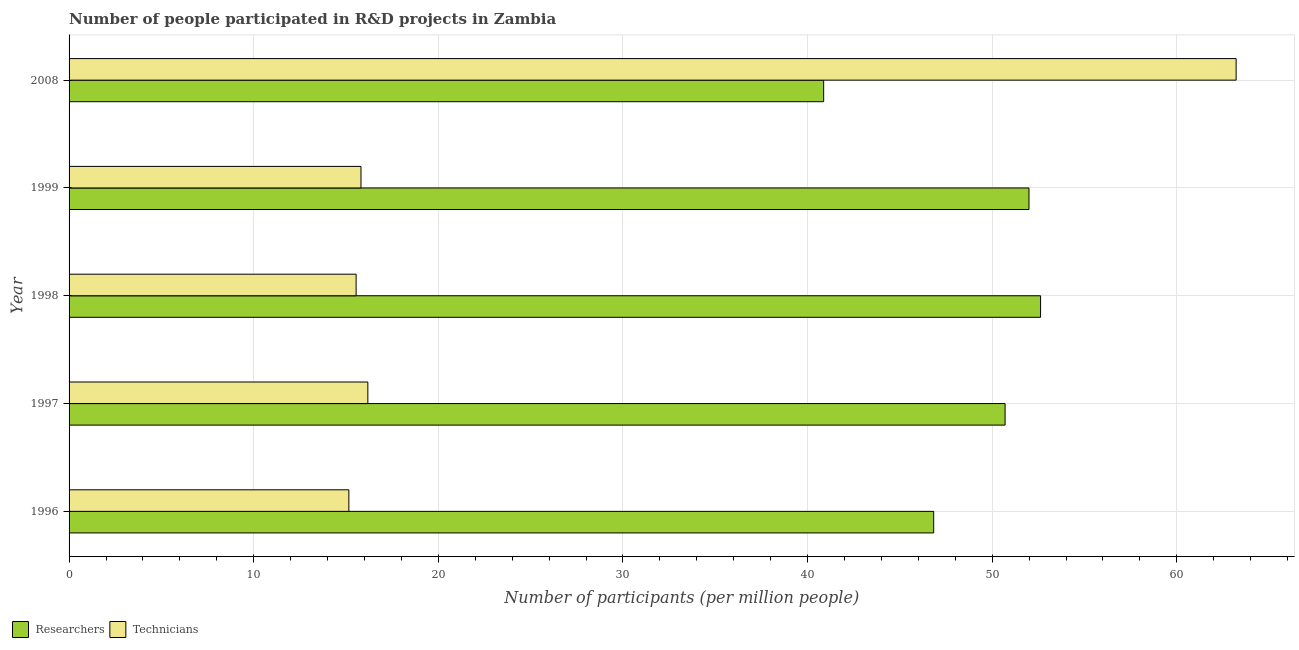How many different coloured bars are there?
Ensure brevity in your answer.  2. What is the label of the 4th group of bars from the top?
Your response must be concise. 1997. In how many cases, is the number of bars for a given year not equal to the number of legend labels?
Offer a terse response. 0. What is the number of researchers in 2008?
Your answer should be compact. 40.87. Across all years, what is the maximum number of technicians?
Your answer should be very brief. 63.21. Across all years, what is the minimum number of researchers?
Make the answer very short. 40.87. What is the total number of researchers in the graph?
Your answer should be compact. 243.01. What is the difference between the number of researchers in 1998 and that in 2008?
Ensure brevity in your answer.  11.75. What is the difference between the number of technicians in 1997 and the number of researchers in 2008?
Your answer should be very brief. -24.69. What is the average number of researchers per year?
Keep it short and to the point. 48.6. In the year 2008, what is the difference between the number of researchers and number of technicians?
Provide a short and direct response. -22.34. In how many years, is the number of technicians greater than 20 ?
Ensure brevity in your answer.  1. What is the ratio of the number of technicians in 1996 to that in 1997?
Give a very brief answer. 0.94. Is the number of researchers in 1996 less than that in 1997?
Keep it short and to the point. Yes. Is the difference between the number of researchers in 1997 and 1998 greater than the difference between the number of technicians in 1997 and 1998?
Keep it short and to the point. No. What is the difference between the highest and the second highest number of technicians?
Your answer should be very brief. 47.03. What is the difference between the highest and the lowest number of researchers?
Offer a very short reply. 11.75. What does the 1st bar from the top in 1999 represents?
Offer a very short reply. Technicians. What does the 2nd bar from the bottom in 1997 represents?
Give a very brief answer. Technicians. Are all the bars in the graph horizontal?
Ensure brevity in your answer.  Yes. How many years are there in the graph?
Give a very brief answer. 5. What is the difference between two consecutive major ticks on the X-axis?
Your response must be concise. 10. Are the values on the major ticks of X-axis written in scientific E-notation?
Provide a succinct answer. No. How are the legend labels stacked?
Provide a short and direct response. Horizontal. What is the title of the graph?
Keep it short and to the point. Number of people participated in R&D projects in Zambia. Does "Rural Population" appear as one of the legend labels in the graph?
Provide a short and direct response. No. What is the label or title of the X-axis?
Give a very brief answer. Number of participants (per million people). What is the label or title of the Y-axis?
Provide a succinct answer. Year. What is the Number of participants (per million people) of Researchers in 1996?
Your response must be concise. 46.83. What is the Number of participants (per million people) of Technicians in 1996?
Ensure brevity in your answer.  15.15. What is the Number of participants (per million people) in Researchers in 1997?
Provide a short and direct response. 50.7. What is the Number of participants (per million people) of Technicians in 1997?
Provide a short and direct response. 16.18. What is the Number of participants (per million people) of Researchers in 1998?
Offer a terse response. 52.62. What is the Number of participants (per million people) of Technicians in 1998?
Ensure brevity in your answer.  15.55. What is the Number of participants (per million people) of Researchers in 1999?
Make the answer very short. 51.99. What is the Number of participants (per million people) in Technicians in 1999?
Keep it short and to the point. 15.81. What is the Number of participants (per million people) in Researchers in 2008?
Your response must be concise. 40.87. What is the Number of participants (per million people) of Technicians in 2008?
Provide a succinct answer. 63.21. Across all years, what is the maximum Number of participants (per million people) of Researchers?
Your response must be concise. 52.62. Across all years, what is the maximum Number of participants (per million people) in Technicians?
Make the answer very short. 63.21. Across all years, what is the minimum Number of participants (per million people) in Researchers?
Your response must be concise. 40.87. Across all years, what is the minimum Number of participants (per million people) of Technicians?
Provide a succinct answer. 15.15. What is the total Number of participants (per million people) in Researchers in the graph?
Offer a very short reply. 243.01. What is the total Number of participants (per million people) in Technicians in the graph?
Offer a very short reply. 125.91. What is the difference between the Number of participants (per million people) of Researchers in 1996 and that in 1997?
Your answer should be compact. -3.87. What is the difference between the Number of participants (per million people) in Technicians in 1996 and that in 1997?
Ensure brevity in your answer.  -1.03. What is the difference between the Number of participants (per million people) of Researchers in 1996 and that in 1998?
Give a very brief answer. -5.79. What is the difference between the Number of participants (per million people) in Technicians in 1996 and that in 1998?
Give a very brief answer. -0.39. What is the difference between the Number of participants (per million people) in Researchers in 1996 and that in 1999?
Your answer should be very brief. -5.16. What is the difference between the Number of participants (per million people) of Technicians in 1996 and that in 1999?
Offer a very short reply. -0.66. What is the difference between the Number of participants (per million people) of Researchers in 1996 and that in 2008?
Your answer should be very brief. 5.96. What is the difference between the Number of participants (per million people) in Technicians in 1996 and that in 2008?
Offer a terse response. -48.06. What is the difference between the Number of participants (per million people) in Researchers in 1997 and that in 1998?
Your response must be concise. -1.92. What is the difference between the Number of participants (per million people) of Technicians in 1997 and that in 1998?
Your answer should be very brief. 0.64. What is the difference between the Number of participants (per million people) in Researchers in 1997 and that in 1999?
Provide a short and direct response. -1.29. What is the difference between the Number of participants (per million people) in Technicians in 1997 and that in 1999?
Offer a terse response. 0.37. What is the difference between the Number of participants (per million people) in Researchers in 1997 and that in 2008?
Your answer should be compact. 9.83. What is the difference between the Number of participants (per million people) of Technicians in 1997 and that in 2008?
Give a very brief answer. -47.03. What is the difference between the Number of participants (per million people) in Researchers in 1998 and that in 1999?
Offer a very short reply. 0.63. What is the difference between the Number of participants (per million people) in Technicians in 1998 and that in 1999?
Your answer should be very brief. -0.26. What is the difference between the Number of participants (per million people) in Researchers in 1998 and that in 2008?
Your response must be concise. 11.75. What is the difference between the Number of participants (per million people) of Technicians in 1998 and that in 2008?
Offer a very short reply. -47.67. What is the difference between the Number of participants (per million people) in Researchers in 1999 and that in 2008?
Offer a very short reply. 11.12. What is the difference between the Number of participants (per million people) in Technicians in 1999 and that in 2008?
Your answer should be very brief. -47.4. What is the difference between the Number of participants (per million people) of Researchers in 1996 and the Number of participants (per million people) of Technicians in 1997?
Provide a succinct answer. 30.65. What is the difference between the Number of participants (per million people) of Researchers in 1996 and the Number of participants (per million people) of Technicians in 1998?
Ensure brevity in your answer.  31.28. What is the difference between the Number of participants (per million people) in Researchers in 1996 and the Number of participants (per million people) in Technicians in 1999?
Offer a very short reply. 31.02. What is the difference between the Number of participants (per million people) in Researchers in 1996 and the Number of participants (per million people) in Technicians in 2008?
Give a very brief answer. -16.38. What is the difference between the Number of participants (per million people) in Researchers in 1997 and the Number of participants (per million people) in Technicians in 1998?
Provide a short and direct response. 35.15. What is the difference between the Number of participants (per million people) in Researchers in 1997 and the Number of participants (per million people) in Technicians in 1999?
Offer a very short reply. 34.89. What is the difference between the Number of participants (per million people) of Researchers in 1997 and the Number of participants (per million people) of Technicians in 2008?
Provide a short and direct response. -12.51. What is the difference between the Number of participants (per million people) of Researchers in 1998 and the Number of participants (per million people) of Technicians in 1999?
Make the answer very short. 36.81. What is the difference between the Number of participants (per million people) in Researchers in 1998 and the Number of participants (per million people) in Technicians in 2008?
Your response must be concise. -10.59. What is the difference between the Number of participants (per million people) in Researchers in 1999 and the Number of participants (per million people) in Technicians in 2008?
Offer a terse response. -11.22. What is the average Number of participants (per million people) of Researchers per year?
Your answer should be compact. 48.6. What is the average Number of participants (per million people) of Technicians per year?
Ensure brevity in your answer.  25.18. In the year 1996, what is the difference between the Number of participants (per million people) in Researchers and Number of participants (per million people) in Technicians?
Your response must be concise. 31.68. In the year 1997, what is the difference between the Number of participants (per million people) in Researchers and Number of participants (per million people) in Technicians?
Provide a succinct answer. 34.52. In the year 1998, what is the difference between the Number of participants (per million people) in Researchers and Number of participants (per million people) in Technicians?
Keep it short and to the point. 37.07. In the year 1999, what is the difference between the Number of participants (per million people) of Researchers and Number of participants (per million people) of Technicians?
Ensure brevity in your answer.  36.18. In the year 2008, what is the difference between the Number of participants (per million people) of Researchers and Number of participants (per million people) of Technicians?
Offer a very short reply. -22.34. What is the ratio of the Number of participants (per million people) in Researchers in 1996 to that in 1997?
Offer a terse response. 0.92. What is the ratio of the Number of participants (per million people) of Technicians in 1996 to that in 1997?
Your answer should be very brief. 0.94. What is the ratio of the Number of participants (per million people) in Researchers in 1996 to that in 1998?
Offer a very short reply. 0.89. What is the ratio of the Number of participants (per million people) in Technicians in 1996 to that in 1998?
Ensure brevity in your answer.  0.97. What is the ratio of the Number of participants (per million people) in Researchers in 1996 to that in 1999?
Offer a very short reply. 0.9. What is the ratio of the Number of participants (per million people) in Technicians in 1996 to that in 1999?
Provide a succinct answer. 0.96. What is the ratio of the Number of participants (per million people) of Researchers in 1996 to that in 2008?
Keep it short and to the point. 1.15. What is the ratio of the Number of participants (per million people) of Technicians in 1996 to that in 2008?
Ensure brevity in your answer.  0.24. What is the ratio of the Number of participants (per million people) in Researchers in 1997 to that in 1998?
Your answer should be compact. 0.96. What is the ratio of the Number of participants (per million people) in Technicians in 1997 to that in 1998?
Provide a short and direct response. 1.04. What is the ratio of the Number of participants (per million people) in Researchers in 1997 to that in 1999?
Provide a succinct answer. 0.98. What is the ratio of the Number of participants (per million people) in Technicians in 1997 to that in 1999?
Offer a very short reply. 1.02. What is the ratio of the Number of participants (per million people) in Researchers in 1997 to that in 2008?
Offer a terse response. 1.24. What is the ratio of the Number of participants (per million people) of Technicians in 1997 to that in 2008?
Provide a short and direct response. 0.26. What is the ratio of the Number of participants (per million people) in Researchers in 1998 to that in 1999?
Make the answer very short. 1.01. What is the ratio of the Number of participants (per million people) in Technicians in 1998 to that in 1999?
Offer a very short reply. 0.98. What is the ratio of the Number of participants (per million people) in Researchers in 1998 to that in 2008?
Offer a terse response. 1.29. What is the ratio of the Number of participants (per million people) in Technicians in 1998 to that in 2008?
Provide a short and direct response. 0.25. What is the ratio of the Number of participants (per million people) in Researchers in 1999 to that in 2008?
Give a very brief answer. 1.27. What is the ratio of the Number of participants (per million people) of Technicians in 1999 to that in 2008?
Offer a very short reply. 0.25. What is the difference between the highest and the second highest Number of participants (per million people) of Researchers?
Make the answer very short. 0.63. What is the difference between the highest and the second highest Number of participants (per million people) of Technicians?
Your answer should be compact. 47.03. What is the difference between the highest and the lowest Number of participants (per million people) in Researchers?
Your answer should be compact. 11.75. What is the difference between the highest and the lowest Number of participants (per million people) in Technicians?
Offer a terse response. 48.06. 